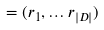Convert formula to latex. <formula><loc_0><loc_0><loc_500><loc_500>= ( r _ { 1 } , \dots r _ { | D | } )</formula> 